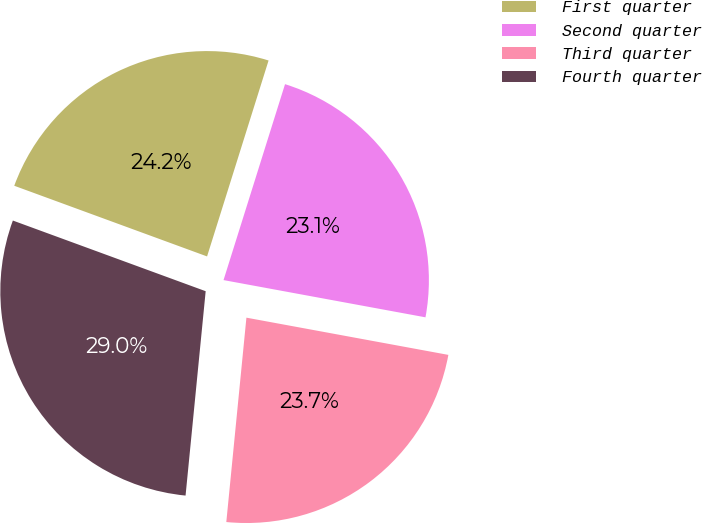<chart> <loc_0><loc_0><loc_500><loc_500><pie_chart><fcel>First quarter<fcel>Second quarter<fcel>Third quarter<fcel>Fourth quarter<nl><fcel>24.25%<fcel>23.06%<fcel>23.66%<fcel>29.03%<nl></chart> 